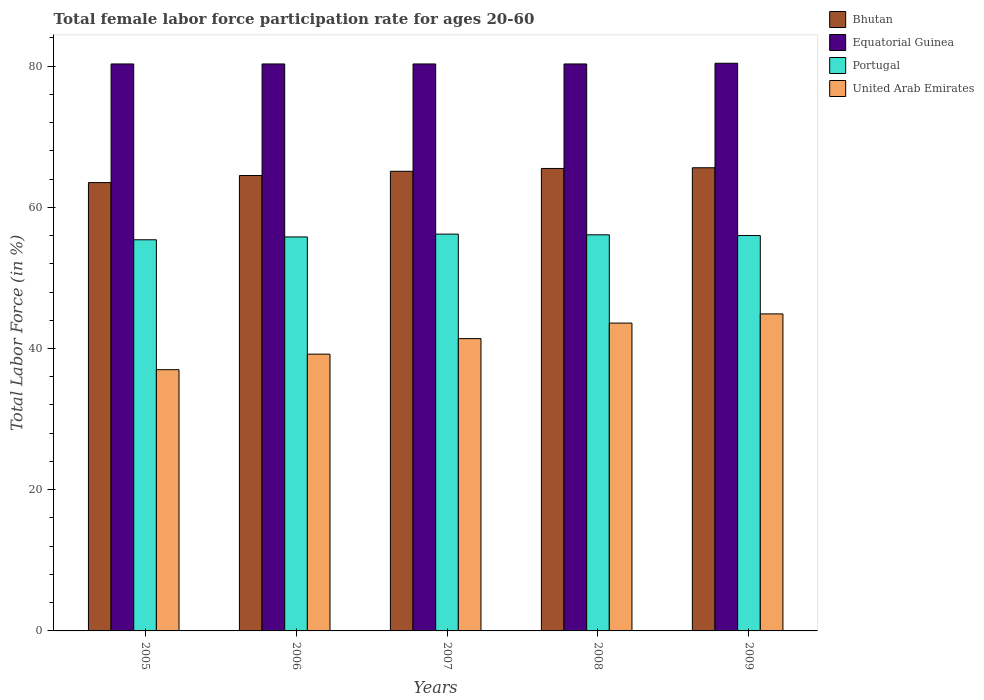How many different coloured bars are there?
Provide a short and direct response. 4. How many bars are there on the 4th tick from the right?
Provide a short and direct response. 4. What is the label of the 3rd group of bars from the left?
Provide a succinct answer. 2007. What is the female labor force participation rate in Bhutan in 2006?
Provide a short and direct response. 64.5. Across all years, what is the maximum female labor force participation rate in Equatorial Guinea?
Provide a short and direct response. 80.4. What is the total female labor force participation rate in Equatorial Guinea in the graph?
Provide a succinct answer. 401.6. What is the difference between the female labor force participation rate in United Arab Emirates in 2006 and that in 2008?
Offer a very short reply. -4.4. What is the difference between the female labor force participation rate in United Arab Emirates in 2007 and the female labor force participation rate in Portugal in 2009?
Your answer should be very brief. -14.6. What is the average female labor force participation rate in United Arab Emirates per year?
Ensure brevity in your answer.  41.22. In the year 2007, what is the difference between the female labor force participation rate in Bhutan and female labor force participation rate in United Arab Emirates?
Your answer should be compact. 23.7. What is the ratio of the female labor force participation rate in United Arab Emirates in 2008 to that in 2009?
Provide a succinct answer. 0.97. What is the difference between the highest and the second highest female labor force participation rate in United Arab Emirates?
Your answer should be very brief. 1.3. What is the difference between the highest and the lowest female labor force participation rate in Bhutan?
Your answer should be very brief. 2.1. In how many years, is the female labor force participation rate in United Arab Emirates greater than the average female labor force participation rate in United Arab Emirates taken over all years?
Your answer should be very brief. 3. Is the sum of the female labor force participation rate in Equatorial Guinea in 2006 and 2009 greater than the maximum female labor force participation rate in United Arab Emirates across all years?
Offer a terse response. Yes. Is it the case that in every year, the sum of the female labor force participation rate in United Arab Emirates and female labor force participation rate in Equatorial Guinea is greater than the sum of female labor force participation rate in Bhutan and female labor force participation rate in Portugal?
Your answer should be very brief. Yes. What does the 1st bar from the left in 2005 represents?
Give a very brief answer. Bhutan. Are all the bars in the graph horizontal?
Ensure brevity in your answer.  No. What is the difference between two consecutive major ticks on the Y-axis?
Your response must be concise. 20. Are the values on the major ticks of Y-axis written in scientific E-notation?
Offer a terse response. No. Does the graph contain grids?
Offer a very short reply. No. Where does the legend appear in the graph?
Your answer should be very brief. Top right. How many legend labels are there?
Offer a terse response. 4. How are the legend labels stacked?
Your answer should be very brief. Vertical. What is the title of the graph?
Provide a succinct answer. Total female labor force participation rate for ages 20-60. What is the Total Labor Force (in %) of Bhutan in 2005?
Provide a succinct answer. 63.5. What is the Total Labor Force (in %) in Equatorial Guinea in 2005?
Offer a terse response. 80.3. What is the Total Labor Force (in %) in Portugal in 2005?
Ensure brevity in your answer.  55.4. What is the Total Labor Force (in %) in United Arab Emirates in 2005?
Your answer should be very brief. 37. What is the Total Labor Force (in %) in Bhutan in 2006?
Keep it short and to the point. 64.5. What is the Total Labor Force (in %) in Equatorial Guinea in 2006?
Offer a very short reply. 80.3. What is the Total Labor Force (in %) in Portugal in 2006?
Your answer should be very brief. 55.8. What is the Total Labor Force (in %) in United Arab Emirates in 2006?
Provide a short and direct response. 39.2. What is the Total Labor Force (in %) of Bhutan in 2007?
Ensure brevity in your answer.  65.1. What is the Total Labor Force (in %) in Equatorial Guinea in 2007?
Make the answer very short. 80.3. What is the Total Labor Force (in %) of Portugal in 2007?
Give a very brief answer. 56.2. What is the Total Labor Force (in %) of United Arab Emirates in 2007?
Keep it short and to the point. 41.4. What is the Total Labor Force (in %) in Bhutan in 2008?
Your answer should be compact. 65.5. What is the Total Labor Force (in %) in Equatorial Guinea in 2008?
Provide a short and direct response. 80.3. What is the Total Labor Force (in %) in Portugal in 2008?
Provide a succinct answer. 56.1. What is the Total Labor Force (in %) of United Arab Emirates in 2008?
Provide a short and direct response. 43.6. What is the Total Labor Force (in %) of Bhutan in 2009?
Your answer should be very brief. 65.6. What is the Total Labor Force (in %) in Equatorial Guinea in 2009?
Your answer should be compact. 80.4. What is the Total Labor Force (in %) in Portugal in 2009?
Offer a terse response. 56. What is the Total Labor Force (in %) of United Arab Emirates in 2009?
Ensure brevity in your answer.  44.9. Across all years, what is the maximum Total Labor Force (in %) in Bhutan?
Provide a short and direct response. 65.6. Across all years, what is the maximum Total Labor Force (in %) in Equatorial Guinea?
Your response must be concise. 80.4. Across all years, what is the maximum Total Labor Force (in %) of Portugal?
Offer a terse response. 56.2. Across all years, what is the maximum Total Labor Force (in %) of United Arab Emirates?
Keep it short and to the point. 44.9. Across all years, what is the minimum Total Labor Force (in %) in Bhutan?
Your response must be concise. 63.5. Across all years, what is the minimum Total Labor Force (in %) in Equatorial Guinea?
Provide a succinct answer. 80.3. Across all years, what is the minimum Total Labor Force (in %) in Portugal?
Offer a terse response. 55.4. What is the total Total Labor Force (in %) in Bhutan in the graph?
Make the answer very short. 324.2. What is the total Total Labor Force (in %) of Equatorial Guinea in the graph?
Make the answer very short. 401.6. What is the total Total Labor Force (in %) of Portugal in the graph?
Offer a terse response. 279.5. What is the total Total Labor Force (in %) of United Arab Emirates in the graph?
Ensure brevity in your answer.  206.1. What is the difference between the Total Labor Force (in %) of Bhutan in 2005 and that in 2006?
Your response must be concise. -1. What is the difference between the Total Labor Force (in %) of Equatorial Guinea in 2005 and that in 2006?
Offer a very short reply. 0. What is the difference between the Total Labor Force (in %) of United Arab Emirates in 2005 and that in 2006?
Keep it short and to the point. -2.2. What is the difference between the Total Labor Force (in %) in Bhutan in 2005 and that in 2007?
Make the answer very short. -1.6. What is the difference between the Total Labor Force (in %) in Equatorial Guinea in 2005 and that in 2007?
Make the answer very short. 0. What is the difference between the Total Labor Force (in %) in Portugal in 2005 and that in 2007?
Your answer should be very brief. -0.8. What is the difference between the Total Labor Force (in %) in Portugal in 2005 and that in 2008?
Offer a very short reply. -0.7. What is the difference between the Total Labor Force (in %) of United Arab Emirates in 2005 and that in 2008?
Make the answer very short. -6.6. What is the difference between the Total Labor Force (in %) in Equatorial Guinea in 2005 and that in 2009?
Offer a terse response. -0.1. What is the difference between the Total Labor Force (in %) in Portugal in 2005 and that in 2009?
Offer a terse response. -0.6. What is the difference between the Total Labor Force (in %) in Equatorial Guinea in 2006 and that in 2007?
Provide a short and direct response. 0. What is the difference between the Total Labor Force (in %) in United Arab Emirates in 2006 and that in 2007?
Your answer should be very brief. -2.2. What is the difference between the Total Labor Force (in %) in Equatorial Guinea in 2006 and that in 2008?
Your answer should be compact. 0. What is the difference between the Total Labor Force (in %) in Portugal in 2006 and that in 2008?
Keep it short and to the point. -0.3. What is the difference between the Total Labor Force (in %) of Bhutan in 2006 and that in 2009?
Keep it short and to the point. -1.1. What is the difference between the Total Labor Force (in %) in Portugal in 2006 and that in 2009?
Keep it short and to the point. -0.2. What is the difference between the Total Labor Force (in %) in United Arab Emirates in 2006 and that in 2009?
Your answer should be very brief. -5.7. What is the difference between the Total Labor Force (in %) of Bhutan in 2007 and that in 2008?
Provide a short and direct response. -0.4. What is the difference between the Total Labor Force (in %) of Equatorial Guinea in 2007 and that in 2008?
Your answer should be compact. 0. What is the difference between the Total Labor Force (in %) in Portugal in 2007 and that in 2008?
Make the answer very short. 0.1. What is the difference between the Total Labor Force (in %) of Bhutan in 2007 and that in 2009?
Make the answer very short. -0.5. What is the difference between the Total Labor Force (in %) in Portugal in 2007 and that in 2009?
Give a very brief answer. 0.2. What is the difference between the Total Labor Force (in %) of Bhutan in 2008 and that in 2009?
Ensure brevity in your answer.  -0.1. What is the difference between the Total Labor Force (in %) of Bhutan in 2005 and the Total Labor Force (in %) of Equatorial Guinea in 2006?
Your answer should be compact. -16.8. What is the difference between the Total Labor Force (in %) in Bhutan in 2005 and the Total Labor Force (in %) in United Arab Emirates in 2006?
Offer a terse response. 24.3. What is the difference between the Total Labor Force (in %) in Equatorial Guinea in 2005 and the Total Labor Force (in %) in Portugal in 2006?
Offer a very short reply. 24.5. What is the difference between the Total Labor Force (in %) in Equatorial Guinea in 2005 and the Total Labor Force (in %) in United Arab Emirates in 2006?
Your answer should be very brief. 41.1. What is the difference between the Total Labor Force (in %) of Portugal in 2005 and the Total Labor Force (in %) of United Arab Emirates in 2006?
Offer a very short reply. 16.2. What is the difference between the Total Labor Force (in %) of Bhutan in 2005 and the Total Labor Force (in %) of Equatorial Guinea in 2007?
Provide a succinct answer. -16.8. What is the difference between the Total Labor Force (in %) of Bhutan in 2005 and the Total Labor Force (in %) of United Arab Emirates in 2007?
Make the answer very short. 22.1. What is the difference between the Total Labor Force (in %) of Equatorial Guinea in 2005 and the Total Labor Force (in %) of Portugal in 2007?
Your response must be concise. 24.1. What is the difference between the Total Labor Force (in %) of Equatorial Guinea in 2005 and the Total Labor Force (in %) of United Arab Emirates in 2007?
Provide a succinct answer. 38.9. What is the difference between the Total Labor Force (in %) in Portugal in 2005 and the Total Labor Force (in %) in United Arab Emirates in 2007?
Give a very brief answer. 14. What is the difference between the Total Labor Force (in %) in Bhutan in 2005 and the Total Labor Force (in %) in Equatorial Guinea in 2008?
Ensure brevity in your answer.  -16.8. What is the difference between the Total Labor Force (in %) of Bhutan in 2005 and the Total Labor Force (in %) of United Arab Emirates in 2008?
Your answer should be compact. 19.9. What is the difference between the Total Labor Force (in %) in Equatorial Guinea in 2005 and the Total Labor Force (in %) in Portugal in 2008?
Offer a very short reply. 24.2. What is the difference between the Total Labor Force (in %) in Equatorial Guinea in 2005 and the Total Labor Force (in %) in United Arab Emirates in 2008?
Provide a succinct answer. 36.7. What is the difference between the Total Labor Force (in %) in Bhutan in 2005 and the Total Labor Force (in %) in Equatorial Guinea in 2009?
Provide a short and direct response. -16.9. What is the difference between the Total Labor Force (in %) in Bhutan in 2005 and the Total Labor Force (in %) in United Arab Emirates in 2009?
Provide a succinct answer. 18.6. What is the difference between the Total Labor Force (in %) of Equatorial Guinea in 2005 and the Total Labor Force (in %) of Portugal in 2009?
Provide a succinct answer. 24.3. What is the difference between the Total Labor Force (in %) in Equatorial Guinea in 2005 and the Total Labor Force (in %) in United Arab Emirates in 2009?
Offer a terse response. 35.4. What is the difference between the Total Labor Force (in %) in Portugal in 2005 and the Total Labor Force (in %) in United Arab Emirates in 2009?
Your response must be concise. 10.5. What is the difference between the Total Labor Force (in %) of Bhutan in 2006 and the Total Labor Force (in %) of Equatorial Guinea in 2007?
Give a very brief answer. -15.8. What is the difference between the Total Labor Force (in %) in Bhutan in 2006 and the Total Labor Force (in %) in United Arab Emirates in 2007?
Your answer should be compact. 23.1. What is the difference between the Total Labor Force (in %) in Equatorial Guinea in 2006 and the Total Labor Force (in %) in Portugal in 2007?
Give a very brief answer. 24.1. What is the difference between the Total Labor Force (in %) of Equatorial Guinea in 2006 and the Total Labor Force (in %) of United Arab Emirates in 2007?
Offer a terse response. 38.9. What is the difference between the Total Labor Force (in %) of Portugal in 2006 and the Total Labor Force (in %) of United Arab Emirates in 2007?
Provide a succinct answer. 14.4. What is the difference between the Total Labor Force (in %) in Bhutan in 2006 and the Total Labor Force (in %) in Equatorial Guinea in 2008?
Your answer should be compact. -15.8. What is the difference between the Total Labor Force (in %) of Bhutan in 2006 and the Total Labor Force (in %) of United Arab Emirates in 2008?
Provide a succinct answer. 20.9. What is the difference between the Total Labor Force (in %) in Equatorial Guinea in 2006 and the Total Labor Force (in %) in Portugal in 2008?
Provide a short and direct response. 24.2. What is the difference between the Total Labor Force (in %) in Equatorial Guinea in 2006 and the Total Labor Force (in %) in United Arab Emirates in 2008?
Make the answer very short. 36.7. What is the difference between the Total Labor Force (in %) of Portugal in 2006 and the Total Labor Force (in %) of United Arab Emirates in 2008?
Offer a terse response. 12.2. What is the difference between the Total Labor Force (in %) in Bhutan in 2006 and the Total Labor Force (in %) in Equatorial Guinea in 2009?
Give a very brief answer. -15.9. What is the difference between the Total Labor Force (in %) of Bhutan in 2006 and the Total Labor Force (in %) of Portugal in 2009?
Provide a succinct answer. 8.5. What is the difference between the Total Labor Force (in %) of Bhutan in 2006 and the Total Labor Force (in %) of United Arab Emirates in 2009?
Your response must be concise. 19.6. What is the difference between the Total Labor Force (in %) of Equatorial Guinea in 2006 and the Total Labor Force (in %) of Portugal in 2009?
Your answer should be compact. 24.3. What is the difference between the Total Labor Force (in %) of Equatorial Guinea in 2006 and the Total Labor Force (in %) of United Arab Emirates in 2009?
Provide a succinct answer. 35.4. What is the difference between the Total Labor Force (in %) of Portugal in 2006 and the Total Labor Force (in %) of United Arab Emirates in 2009?
Provide a succinct answer. 10.9. What is the difference between the Total Labor Force (in %) in Bhutan in 2007 and the Total Labor Force (in %) in Equatorial Guinea in 2008?
Provide a short and direct response. -15.2. What is the difference between the Total Labor Force (in %) of Bhutan in 2007 and the Total Labor Force (in %) of United Arab Emirates in 2008?
Your response must be concise. 21.5. What is the difference between the Total Labor Force (in %) in Equatorial Guinea in 2007 and the Total Labor Force (in %) in Portugal in 2008?
Provide a short and direct response. 24.2. What is the difference between the Total Labor Force (in %) of Equatorial Guinea in 2007 and the Total Labor Force (in %) of United Arab Emirates in 2008?
Offer a very short reply. 36.7. What is the difference between the Total Labor Force (in %) in Portugal in 2007 and the Total Labor Force (in %) in United Arab Emirates in 2008?
Provide a short and direct response. 12.6. What is the difference between the Total Labor Force (in %) of Bhutan in 2007 and the Total Labor Force (in %) of Equatorial Guinea in 2009?
Give a very brief answer. -15.3. What is the difference between the Total Labor Force (in %) in Bhutan in 2007 and the Total Labor Force (in %) in United Arab Emirates in 2009?
Keep it short and to the point. 20.2. What is the difference between the Total Labor Force (in %) of Equatorial Guinea in 2007 and the Total Labor Force (in %) of Portugal in 2009?
Your response must be concise. 24.3. What is the difference between the Total Labor Force (in %) in Equatorial Guinea in 2007 and the Total Labor Force (in %) in United Arab Emirates in 2009?
Your answer should be very brief. 35.4. What is the difference between the Total Labor Force (in %) in Portugal in 2007 and the Total Labor Force (in %) in United Arab Emirates in 2009?
Give a very brief answer. 11.3. What is the difference between the Total Labor Force (in %) in Bhutan in 2008 and the Total Labor Force (in %) in Equatorial Guinea in 2009?
Offer a terse response. -14.9. What is the difference between the Total Labor Force (in %) in Bhutan in 2008 and the Total Labor Force (in %) in United Arab Emirates in 2009?
Your response must be concise. 20.6. What is the difference between the Total Labor Force (in %) of Equatorial Guinea in 2008 and the Total Labor Force (in %) of Portugal in 2009?
Ensure brevity in your answer.  24.3. What is the difference between the Total Labor Force (in %) in Equatorial Guinea in 2008 and the Total Labor Force (in %) in United Arab Emirates in 2009?
Keep it short and to the point. 35.4. What is the difference between the Total Labor Force (in %) in Portugal in 2008 and the Total Labor Force (in %) in United Arab Emirates in 2009?
Your answer should be very brief. 11.2. What is the average Total Labor Force (in %) of Bhutan per year?
Your answer should be very brief. 64.84. What is the average Total Labor Force (in %) of Equatorial Guinea per year?
Offer a terse response. 80.32. What is the average Total Labor Force (in %) in Portugal per year?
Offer a terse response. 55.9. What is the average Total Labor Force (in %) in United Arab Emirates per year?
Ensure brevity in your answer.  41.22. In the year 2005, what is the difference between the Total Labor Force (in %) in Bhutan and Total Labor Force (in %) in Equatorial Guinea?
Offer a very short reply. -16.8. In the year 2005, what is the difference between the Total Labor Force (in %) of Bhutan and Total Labor Force (in %) of United Arab Emirates?
Give a very brief answer. 26.5. In the year 2005, what is the difference between the Total Labor Force (in %) in Equatorial Guinea and Total Labor Force (in %) in Portugal?
Ensure brevity in your answer.  24.9. In the year 2005, what is the difference between the Total Labor Force (in %) of Equatorial Guinea and Total Labor Force (in %) of United Arab Emirates?
Give a very brief answer. 43.3. In the year 2005, what is the difference between the Total Labor Force (in %) of Portugal and Total Labor Force (in %) of United Arab Emirates?
Your answer should be very brief. 18.4. In the year 2006, what is the difference between the Total Labor Force (in %) of Bhutan and Total Labor Force (in %) of Equatorial Guinea?
Offer a terse response. -15.8. In the year 2006, what is the difference between the Total Labor Force (in %) of Bhutan and Total Labor Force (in %) of United Arab Emirates?
Make the answer very short. 25.3. In the year 2006, what is the difference between the Total Labor Force (in %) of Equatorial Guinea and Total Labor Force (in %) of United Arab Emirates?
Your answer should be compact. 41.1. In the year 2006, what is the difference between the Total Labor Force (in %) in Portugal and Total Labor Force (in %) in United Arab Emirates?
Keep it short and to the point. 16.6. In the year 2007, what is the difference between the Total Labor Force (in %) of Bhutan and Total Labor Force (in %) of Equatorial Guinea?
Offer a terse response. -15.2. In the year 2007, what is the difference between the Total Labor Force (in %) of Bhutan and Total Labor Force (in %) of Portugal?
Your answer should be compact. 8.9. In the year 2007, what is the difference between the Total Labor Force (in %) of Bhutan and Total Labor Force (in %) of United Arab Emirates?
Make the answer very short. 23.7. In the year 2007, what is the difference between the Total Labor Force (in %) of Equatorial Guinea and Total Labor Force (in %) of Portugal?
Make the answer very short. 24.1. In the year 2007, what is the difference between the Total Labor Force (in %) in Equatorial Guinea and Total Labor Force (in %) in United Arab Emirates?
Ensure brevity in your answer.  38.9. In the year 2008, what is the difference between the Total Labor Force (in %) of Bhutan and Total Labor Force (in %) of Equatorial Guinea?
Make the answer very short. -14.8. In the year 2008, what is the difference between the Total Labor Force (in %) in Bhutan and Total Labor Force (in %) in Portugal?
Provide a succinct answer. 9.4. In the year 2008, what is the difference between the Total Labor Force (in %) of Bhutan and Total Labor Force (in %) of United Arab Emirates?
Provide a short and direct response. 21.9. In the year 2008, what is the difference between the Total Labor Force (in %) in Equatorial Guinea and Total Labor Force (in %) in Portugal?
Offer a terse response. 24.2. In the year 2008, what is the difference between the Total Labor Force (in %) in Equatorial Guinea and Total Labor Force (in %) in United Arab Emirates?
Your answer should be compact. 36.7. In the year 2009, what is the difference between the Total Labor Force (in %) of Bhutan and Total Labor Force (in %) of Equatorial Guinea?
Offer a terse response. -14.8. In the year 2009, what is the difference between the Total Labor Force (in %) of Bhutan and Total Labor Force (in %) of Portugal?
Give a very brief answer. 9.6. In the year 2009, what is the difference between the Total Labor Force (in %) in Bhutan and Total Labor Force (in %) in United Arab Emirates?
Offer a very short reply. 20.7. In the year 2009, what is the difference between the Total Labor Force (in %) of Equatorial Guinea and Total Labor Force (in %) of Portugal?
Offer a very short reply. 24.4. In the year 2009, what is the difference between the Total Labor Force (in %) in Equatorial Guinea and Total Labor Force (in %) in United Arab Emirates?
Your answer should be compact. 35.5. In the year 2009, what is the difference between the Total Labor Force (in %) of Portugal and Total Labor Force (in %) of United Arab Emirates?
Your response must be concise. 11.1. What is the ratio of the Total Labor Force (in %) of Bhutan in 2005 to that in 2006?
Your answer should be very brief. 0.98. What is the ratio of the Total Labor Force (in %) in Portugal in 2005 to that in 2006?
Offer a very short reply. 0.99. What is the ratio of the Total Labor Force (in %) in United Arab Emirates in 2005 to that in 2006?
Provide a succinct answer. 0.94. What is the ratio of the Total Labor Force (in %) of Bhutan in 2005 to that in 2007?
Offer a terse response. 0.98. What is the ratio of the Total Labor Force (in %) of Equatorial Guinea in 2005 to that in 2007?
Your answer should be compact. 1. What is the ratio of the Total Labor Force (in %) of Portugal in 2005 to that in 2007?
Give a very brief answer. 0.99. What is the ratio of the Total Labor Force (in %) in United Arab Emirates in 2005 to that in 2007?
Your response must be concise. 0.89. What is the ratio of the Total Labor Force (in %) in Bhutan in 2005 to that in 2008?
Provide a short and direct response. 0.97. What is the ratio of the Total Labor Force (in %) of Equatorial Guinea in 2005 to that in 2008?
Offer a terse response. 1. What is the ratio of the Total Labor Force (in %) of Portugal in 2005 to that in 2008?
Your answer should be very brief. 0.99. What is the ratio of the Total Labor Force (in %) of United Arab Emirates in 2005 to that in 2008?
Ensure brevity in your answer.  0.85. What is the ratio of the Total Labor Force (in %) of Equatorial Guinea in 2005 to that in 2009?
Make the answer very short. 1. What is the ratio of the Total Labor Force (in %) in Portugal in 2005 to that in 2009?
Ensure brevity in your answer.  0.99. What is the ratio of the Total Labor Force (in %) in United Arab Emirates in 2005 to that in 2009?
Offer a very short reply. 0.82. What is the ratio of the Total Labor Force (in %) of Bhutan in 2006 to that in 2007?
Offer a terse response. 0.99. What is the ratio of the Total Labor Force (in %) of Equatorial Guinea in 2006 to that in 2007?
Keep it short and to the point. 1. What is the ratio of the Total Labor Force (in %) of Portugal in 2006 to that in 2007?
Offer a terse response. 0.99. What is the ratio of the Total Labor Force (in %) in United Arab Emirates in 2006 to that in 2007?
Provide a succinct answer. 0.95. What is the ratio of the Total Labor Force (in %) of Bhutan in 2006 to that in 2008?
Make the answer very short. 0.98. What is the ratio of the Total Labor Force (in %) of Equatorial Guinea in 2006 to that in 2008?
Provide a short and direct response. 1. What is the ratio of the Total Labor Force (in %) in Portugal in 2006 to that in 2008?
Offer a terse response. 0.99. What is the ratio of the Total Labor Force (in %) in United Arab Emirates in 2006 to that in 2008?
Offer a terse response. 0.9. What is the ratio of the Total Labor Force (in %) of Bhutan in 2006 to that in 2009?
Your answer should be compact. 0.98. What is the ratio of the Total Labor Force (in %) in Equatorial Guinea in 2006 to that in 2009?
Ensure brevity in your answer.  1. What is the ratio of the Total Labor Force (in %) in Portugal in 2006 to that in 2009?
Keep it short and to the point. 1. What is the ratio of the Total Labor Force (in %) of United Arab Emirates in 2006 to that in 2009?
Your answer should be compact. 0.87. What is the ratio of the Total Labor Force (in %) in Equatorial Guinea in 2007 to that in 2008?
Your response must be concise. 1. What is the ratio of the Total Labor Force (in %) of Portugal in 2007 to that in 2008?
Your answer should be compact. 1. What is the ratio of the Total Labor Force (in %) in United Arab Emirates in 2007 to that in 2008?
Provide a succinct answer. 0.95. What is the ratio of the Total Labor Force (in %) of Portugal in 2007 to that in 2009?
Keep it short and to the point. 1. What is the ratio of the Total Labor Force (in %) in United Arab Emirates in 2007 to that in 2009?
Provide a short and direct response. 0.92. What is the ratio of the Total Labor Force (in %) in United Arab Emirates in 2008 to that in 2009?
Your response must be concise. 0.97. What is the difference between the highest and the second highest Total Labor Force (in %) in Bhutan?
Provide a succinct answer. 0.1. What is the difference between the highest and the second highest Total Labor Force (in %) in Equatorial Guinea?
Ensure brevity in your answer.  0.1. What is the difference between the highest and the second highest Total Labor Force (in %) of Portugal?
Your answer should be very brief. 0.1. What is the difference between the highest and the lowest Total Labor Force (in %) in Bhutan?
Your response must be concise. 2.1. What is the difference between the highest and the lowest Total Labor Force (in %) in Portugal?
Provide a succinct answer. 0.8. What is the difference between the highest and the lowest Total Labor Force (in %) of United Arab Emirates?
Make the answer very short. 7.9. 